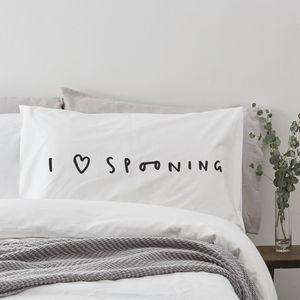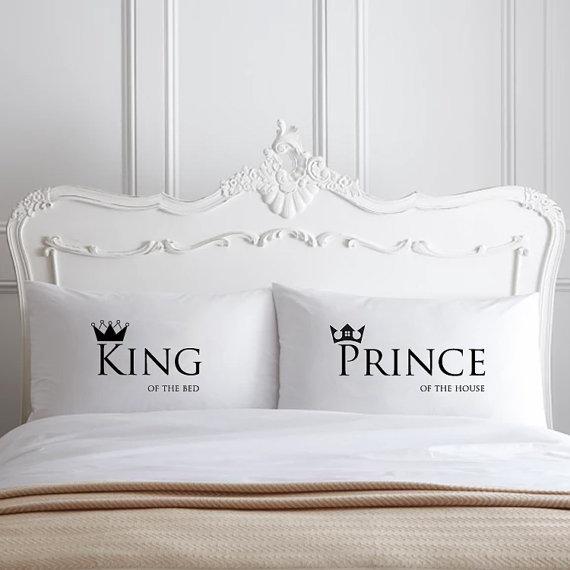The first image is the image on the left, the second image is the image on the right. Assess this claim about the two images: "In one of the images there are 2 pillows resting against a white headboard.". Correct or not? Answer yes or no. Yes. The first image is the image on the left, the second image is the image on the right. For the images shown, is this caption "The left image contains one rectangular pillow with black text on it, and the right image contains side-by-side pillows printed with black text." true? Answer yes or no. Yes. 